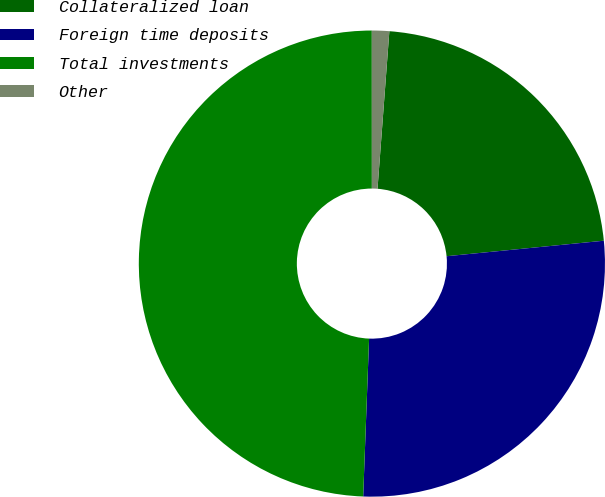Convert chart to OTSL. <chart><loc_0><loc_0><loc_500><loc_500><pie_chart><fcel>Collateralized loan<fcel>Foreign time deposits<fcel>Total investments<fcel>Other<nl><fcel>22.24%<fcel>27.16%<fcel>49.4%<fcel>1.2%<nl></chart> 